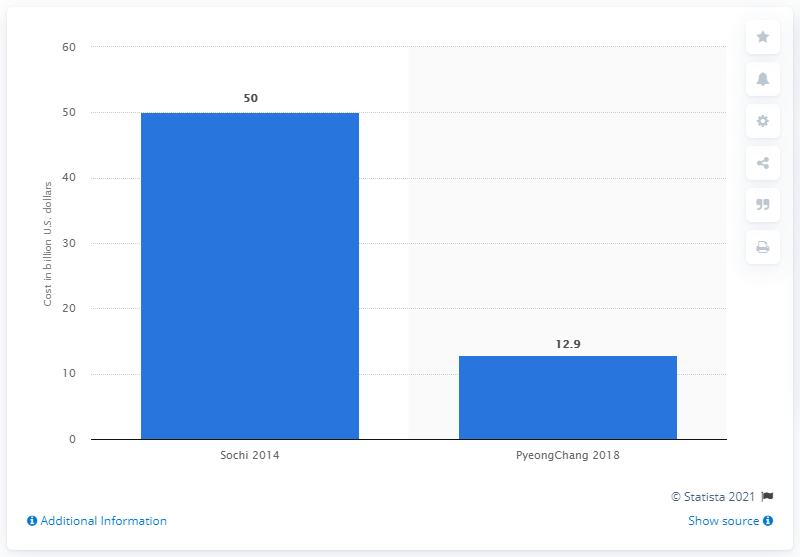Outline some significant characteristics in this image. The cost of the 2018 Winter Olympics in South Korea was approximately 12.9 billion US dollars. 